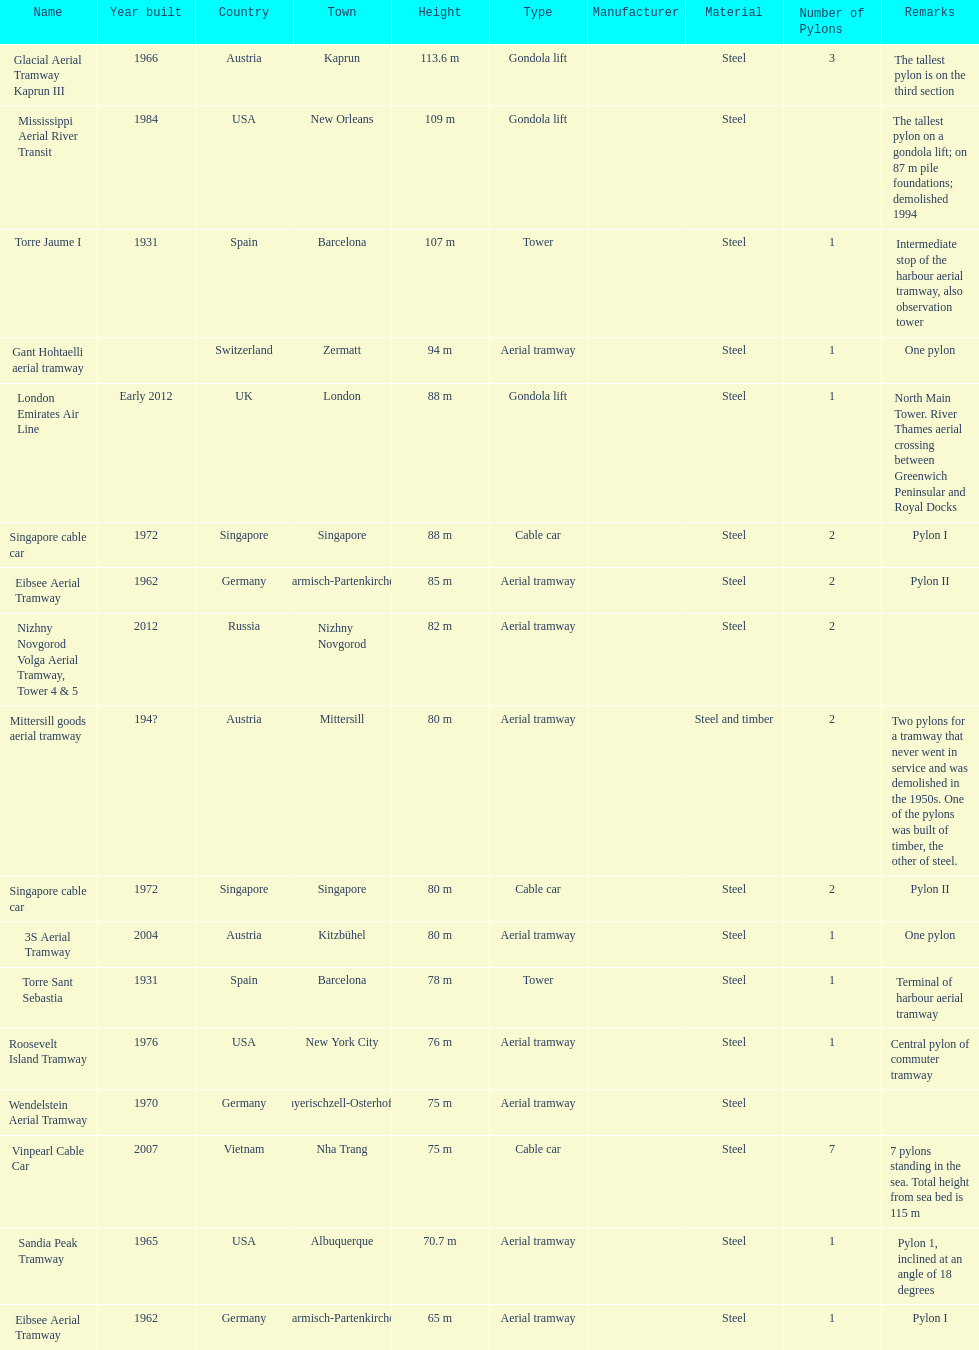What is the pylon with the least height listed here? Eibsee Aerial Tramway. 